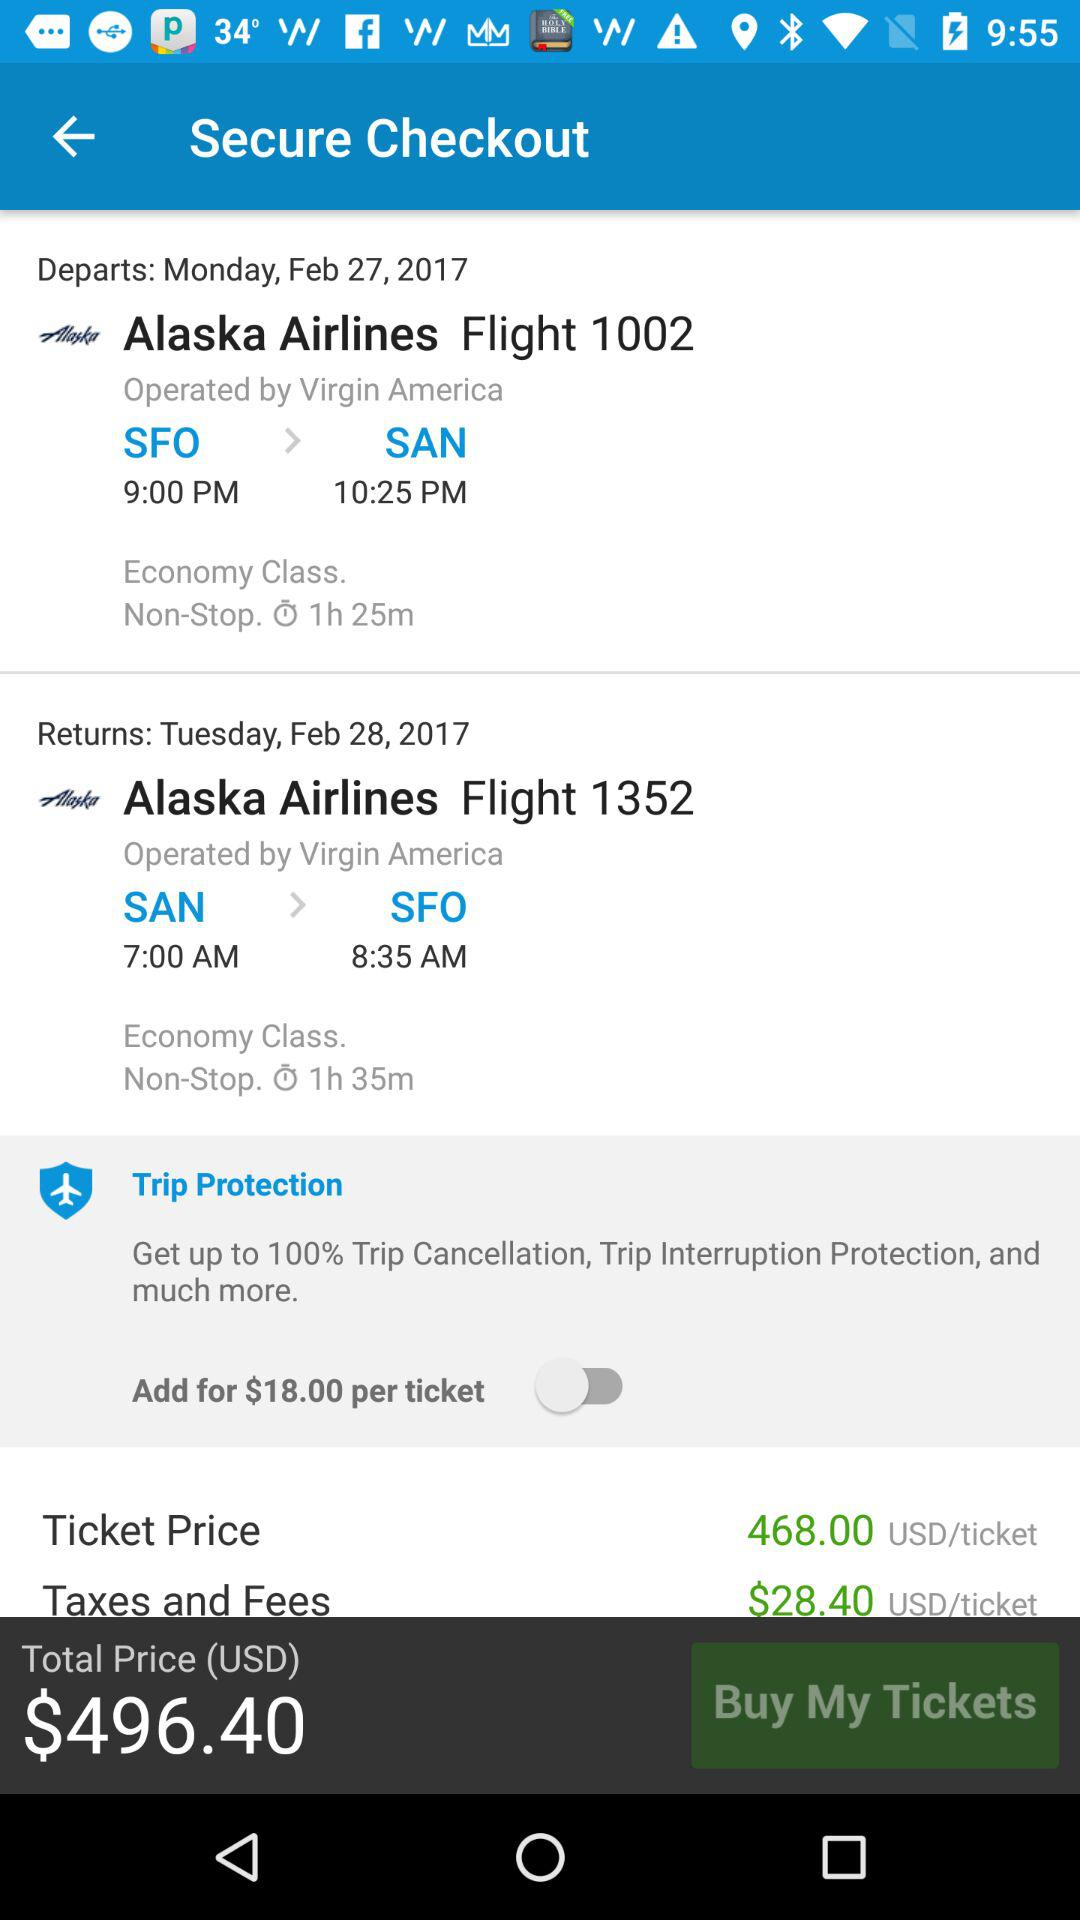What is the departure date and time? The departure date is Monday, Feb. 27, 2017 and the departure time is 9:00 PM. 